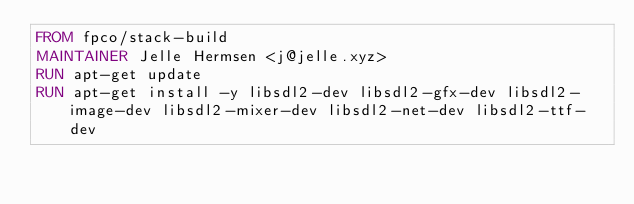Convert code to text. <code><loc_0><loc_0><loc_500><loc_500><_Dockerfile_>FROM fpco/stack-build
MAINTAINER Jelle Hermsen <j@jelle.xyz>
RUN apt-get update
RUN apt-get install -y libsdl2-dev libsdl2-gfx-dev libsdl2-image-dev libsdl2-mixer-dev libsdl2-net-dev libsdl2-ttf-dev
</code> 